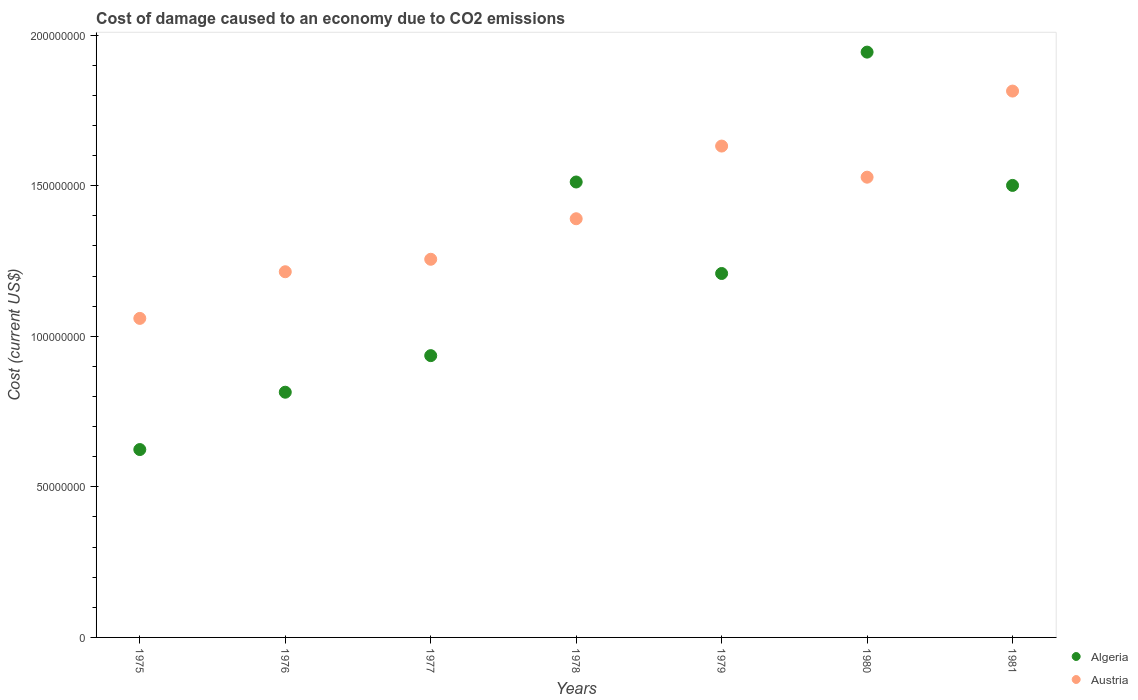What is the cost of damage caused due to CO2 emissisons in Algeria in 1977?
Your answer should be very brief. 9.36e+07. Across all years, what is the maximum cost of damage caused due to CO2 emissisons in Algeria?
Provide a short and direct response. 1.94e+08. Across all years, what is the minimum cost of damage caused due to CO2 emissisons in Austria?
Provide a succinct answer. 1.06e+08. In which year was the cost of damage caused due to CO2 emissisons in Algeria maximum?
Offer a very short reply. 1980. In which year was the cost of damage caused due to CO2 emissisons in Algeria minimum?
Give a very brief answer. 1975. What is the total cost of damage caused due to CO2 emissisons in Austria in the graph?
Keep it short and to the point. 9.89e+08. What is the difference between the cost of damage caused due to CO2 emissisons in Austria in 1976 and that in 1979?
Offer a terse response. -4.17e+07. What is the difference between the cost of damage caused due to CO2 emissisons in Austria in 1979 and the cost of damage caused due to CO2 emissisons in Algeria in 1976?
Offer a terse response. 8.17e+07. What is the average cost of damage caused due to CO2 emissisons in Algeria per year?
Offer a terse response. 1.22e+08. In the year 1977, what is the difference between the cost of damage caused due to CO2 emissisons in Austria and cost of damage caused due to CO2 emissisons in Algeria?
Your answer should be compact. 3.20e+07. What is the ratio of the cost of damage caused due to CO2 emissisons in Algeria in 1975 to that in 1981?
Ensure brevity in your answer.  0.42. Is the difference between the cost of damage caused due to CO2 emissisons in Austria in 1975 and 1981 greater than the difference between the cost of damage caused due to CO2 emissisons in Algeria in 1975 and 1981?
Your answer should be very brief. Yes. What is the difference between the highest and the second highest cost of damage caused due to CO2 emissisons in Austria?
Ensure brevity in your answer.  1.83e+07. What is the difference between the highest and the lowest cost of damage caused due to CO2 emissisons in Algeria?
Keep it short and to the point. 1.32e+08. Is the sum of the cost of damage caused due to CO2 emissisons in Algeria in 1976 and 1978 greater than the maximum cost of damage caused due to CO2 emissisons in Austria across all years?
Provide a short and direct response. Yes. Is the cost of damage caused due to CO2 emissisons in Austria strictly less than the cost of damage caused due to CO2 emissisons in Algeria over the years?
Ensure brevity in your answer.  No. How many dotlines are there?
Your response must be concise. 2. What is the difference between two consecutive major ticks on the Y-axis?
Provide a succinct answer. 5.00e+07. Are the values on the major ticks of Y-axis written in scientific E-notation?
Offer a very short reply. No. Does the graph contain any zero values?
Your response must be concise. No. Does the graph contain grids?
Give a very brief answer. No. How many legend labels are there?
Provide a short and direct response. 2. What is the title of the graph?
Provide a succinct answer. Cost of damage caused to an economy due to CO2 emissions. What is the label or title of the Y-axis?
Keep it short and to the point. Cost (current US$). What is the Cost (current US$) of Algeria in 1975?
Give a very brief answer. 6.24e+07. What is the Cost (current US$) in Austria in 1975?
Make the answer very short. 1.06e+08. What is the Cost (current US$) of Algeria in 1976?
Make the answer very short. 8.14e+07. What is the Cost (current US$) in Austria in 1976?
Your response must be concise. 1.21e+08. What is the Cost (current US$) in Algeria in 1977?
Provide a succinct answer. 9.36e+07. What is the Cost (current US$) of Austria in 1977?
Provide a succinct answer. 1.26e+08. What is the Cost (current US$) of Algeria in 1978?
Offer a very short reply. 1.51e+08. What is the Cost (current US$) of Austria in 1978?
Your response must be concise. 1.39e+08. What is the Cost (current US$) of Algeria in 1979?
Provide a short and direct response. 1.21e+08. What is the Cost (current US$) in Austria in 1979?
Provide a succinct answer. 1.63e+08. What is the Cost (current US$) of Algeria in 1980?
Make the answer very short. 1.94e+08. What is the Cost (current US$) of Austria in 1980?
Your response must be concise. 1.53e+08. What is the Cost (current US$) of Algeria in 1981?
Give a very brief answer. 1.50e+08. What is the Cost (current US$) in Austria in 1981?
Your response must be concise. 1.81e+08. Across all years, what is the maximum Cost (current US$) of Algeria?
Your answer should be very brief. 1.94e+08. Across all years, what is the maximum Cost (current US$) of Austria?
Ensure brevity in your answer.  1.81e+08. Across all years, what is the minimum Cost (current US$) in Algeria?
Your answer should be very brief. 6.24e+07. Across all years, what is the minimum Cost (current US$) in Austria?
Offer a very short reply. 1.06e+08. What is the total Cost (current US$) of Algeria in the graph?
Keep it short and to the point. 8.54e+08. What is the total Cost (current US$) of Austria in the graph?
Offer a terse response. 9.89e+08. What is the difference between the Cost (current US$) of Algeria in 1975 and that in 1976?
Give a very brief answer. -1.90e+07. What is the difference between the Cost (current US$) of Austria in 1975 and that in 1976?
Provide a succinct answer. -1.55e+07. What is the difference between the Cost (current US$) of Algeria in 1975 and that in 1977?
Your response must be concise. -3.12e+07. What is the difference between the Cost (current US$) in Austria in 1975 and that in 1977?
Keep it short and to the point. -1.96e+07. What is the difference between the Cost (current US$) of Algeria in 1975 and that in 1978?
Give a very brief answer. -8.88e+07. What is the difference between the Cost (current US$) of Austria in 1975 and that in 1978?
Make the answer very short. -3.31e+07. What is the difference between the Cost (current US$) in Algeria in 1975 and that in 1979?
Offer a very short reply. -5.85e+07. What is the difference between the Cost (current US$) in Austria in 1975 and that in 1979?
Provide a succinct answer. -5.72e+07. What is the difference between the Cost (current US$) in Algeria in 1975 and that in 1980?
Make the answer very short. -1.32e+08. What is the difference between the Cost (current US$) of Austria in 1975 and that in 1980?
Give a very brief answer. -4.69e+07. What is the difference between the Cost (current US$) of Algeria in 1975 and that in 1981?
Give a very brief answer. -8.77e+07. What is the difference between the Cost (current US$) in Austria in 1975 and that in 1981?
Ensure brevity in your answer.  -7.55e+07. What is the difference between the Cost (current US$) of Algeria in 1976 and that in 1977?
Keep it short and to the point. -1.21e+07. What is the difference between the Cost (current US$) in Austria in 1976 and that in 1977?
Your response must be concise. -4.14e+06. What is the difference between the Cost (current US$) in Algeria in 1976 and that in 1978?
Your answer should be very brief. -6.98e+07. What is the difference between the Cost (current US$) of Austria in 1976 and that in 1978?
Make the answer very short. -1.76e+07. What is the difference between the Cost (current US$) of Algeria in 1976 and that in 1979?
Make the answer very short. -3.94e+07. What is the difference between the Cost (current US$) in Austria in 1976 and that in 1979?
Offer a terse response. -4.17e+07. What is the difference between the Cost (current US$) of Algeria in 1976 and that in 1980?
Ensure brevity in your answer.  -1.13e+08. What is the difference between the Cost (current US$) of Austria in 1976 and that in 1980?
Make the answer very short. -3.14e+07. What is the difference between the Cost (current US$) of Algeria in 1976 and that in 1981?
Provide a succinct answer. -6.87e+07. What is the difference between the Cost (current US$) of Austria in 1976 and that in 1981?
Provide a succinct answer. -6.00e+07. What is the difference between the Cost (current US$) in Algeria in 1977 and that in 1978?
Your answer should be compact. -5.77e+07. What is the difference between the Cost (current US$) of Austria in 1977 and that in 1978?
Offer a very short reply. -1.35e+07. What is the difference between the Cost (current US$) of Algeria in 1977 and that in 1979?
Provide a short and direct response. -2.73e+07. What is the difference between the Cost (current US$) of Austria in 1977 and that in 1979?
Your response must be concise. -3.76e+07. What is the difference between the Cost (current US$) of Algeria in 1977 and that in 1980?
Keep it short and to the point. -1.01e+08. What is the difference between the Cost (current US$) of Austria in 1977 and that in 1980?
Offer a very short reply. -2.73e+07. What is the difference between the Cost (current US$) of Algeria in 1977 and that in 1981?
Offer a terse response. -5.65e+07. What is the difference between the Cost (current US$) in Austria in 1977 and that in 1981?
Your answer should be compact. -5.59e+07. What is the difference between the Cost (current US$) in Algeria in 1978 and that in 1979?
Your answer should be compact. 3.04e+07. What is the difference between the Cost (current US$) in Austria in 1978 and that in 1979?
Offer a very short reply. -2.41e+07. What is the difference between the Cost (current US$) of Algeria in 1978 and that in 1980?
Your response must be concise. -4.31e+07. What is the difference between the Cost (current US$) in Austria in 1978 and that in 1980?
Your answer should be very brief. -1.38e+07. What is the difference between the Cost (current US$) of Algeria in 1978 and that in 1981?
Your response must be concise. 1.13e+06. What is the difference between the Cost (current US$) of Austria in 1978 and that in 1981?
Provide a short and direct response. -4.24e+07. What is the difference between the Cost (current US$) of Algeria in 1979 and that in 1980?
Provide a short and direct response. -7.35e+07. What is the difference between the Cost (current US$) in Austria in 1979 and that in 1980?
Your answer should be very brief. 1.03e+07. What is the difference between the Cost (current US$) of Algeria in 1979 and that in 1981?
Offer a terse response. -2.92e+07. What is the difference between the Cost (current US$) of Austria in 1979 and that in 1981?
Ensure brevity in your answer.  -1.83e+07. What is the difference between the Cost (current US$) in Algeria in 1980 and that in 1981?
Give a very brief answer. 4.43e+07. What is the difference between the Cost (current US$) in Austria in 1980 and that in 1981?
Your response must be concise. -2.86e+07. What is the difference between the Cost (current US$) of Algeria in 1975 and the Cost (current US$) of Austria in 1976?
Your answer should be compact. -5.90e+07. What is the difference between the Cost (current US$) of Algeria in 1975 and the Cost (current US$) of Austria in 1977?
Give a very brief answer. -6.32e+07. What is the difference between the Cost (current US$) of Algeria in 1975 and the Cost (current US$) of Austria in 1978?
Your answer should be compact. -7.66e+07. What is the difference between the Cost (current US$) in Algeria in 1975 and the Cost (current US$) in Austria in 1979?
Your answer should be very brief. -1.01e+08. What is the difference between the Cost (current US$) of Algeria in 1975 and the Cost (current US$) of Austria in 1980?
Give a very brief answer. -9.04e+07. What is the difference between the Cost (current US$) in Algeria in 1975 and the Cost (current US$) in Austria in 1981?
Ensure brevity in your answer.  -1.19e+08. What is the difference between the Cost (current US$) of Algeria in 1976 and the Cost (current US$) of Austria in 1977?
Ensure brevity in your answer.  -4.41e+07. What is the difference between the Cost (current US$) in Algeria in 1976 and the Cost (current US$) in Austria in 1978?
Offer a very short reply. -5.76e+07. What is the difference between the Cost (current US$) of Algeria in 1976 and the Cost (current US$) of Austria in 1979?
Your answer should be very brief. -8.17e+07. What is the difference between the Cost (current US$) in Algeria in 1976 and the Cost (current US$) in Austria in 1980?
Offer a very short reply. -7.14e+07. What is the difference between the Cost (current US$) in Algeria in 1976 and the Cost (current US$) in Austria in 1981?
Give a very brief answer. -1.00e+08. What is the difference between the Cost (current US$) in Algeria in 1977 and the Cost (current US$) in Austria in 1978?
Keep it short and to the point. -4.55e+07. What is the difference between the Cost (current US$) in Algeria in 1977 and the Cost (current US$) in Austria in 1979?
Your answer should be compact. -6.96e+07. What is the difference between the Cost (current US$) in Algeria in 1977 and the Cost (current US$) in Austria in 1980?
Ensure brevity in your answer.  -5.93e+07. What is the difference between the Cost (current US$) of Algeria in 1977 and the Cost (current US$) of Austria in 1981?
Your answer should be compact. -8.79e+07. What is the difference between the Cost (current US$) in Algeria in 1978 and the Cost (current US$) in Austria in 1979?
Your answer should be compact. -1.19e+07. What is the difference between the Cost (current US$) of Algeria in 1978 and the Cost (current US$) of Austria in 1980?
Provide a succinct answer. -1.60e+06. What is the difference between the Cost (current US$) in Algeria in 1978 and the Cost (current US$) in Austria in 1981?
Ensure brevity in your answer.  -3.02e+07. What is the difference between the Cost (current US$) in Algeria in 1979 and the Cost (current US$) in Austria in 1980?
Your answer should be compact. -3.20e+07. What is the difference between the Cost (current US$) of Algeria in 1979 and the Cost (current US$) of Austria in 1981?
Keep it short and to the point. -6.06e+07. What is the difference between the Cost (current US$) of Algeria in 1980 and the Cost (current US$) of Austria in 1981?
Provide a short and direct response. 1.29e+07. What is the average Cost (current US$) of Algeria per year?
Provide a short and direct response. 1.22e+08. What is the average Cost (current US$) in Austria per year?
Offer a terse response. 1.41e+08. In the year 1975, what is the difference between the Cost (current US$) in Algeria and Cost (current US$) in Austria?
Keep it short and to the point. -4.36e+07. In the year 1976, what is the difference between the Cost (current US$) in Algeria and Cost (current US$) in Austria?
Provide a succinct answer. -4.00e+07. In the year 1977, what is the difference between the Cost (current US$) in Algeria and Cost (current US$) in Austria?
Give a very brief answer. -3.20e+07. In the year 1978, what is the difference between the Cost (current US$) in Algeria and Cost (current US$) in Austria?
Your answer should be compact. 1.22e+07. In the year 1979, what is the difference between the Cost (current US$) of Algeria and Cost (current US$) of Austria?
Your answer should be very brief. -4.23e+07. In the year 1980, what is the difference between the Cost (current US$) in Algeria and Cost (current US$) in Austria?
Offer a terse response. 4.15e+07. In the year 1981, what is the difference between the Cost (current US$) of Algeria and Cost (current US$) of Austria?
Provide a succinct answer. -3.13e+07. What is the ratio of the Cost (current US$) in Algeria in 1975 to that in 1976?
Provide a short and direct response. 0.77. What is the ratio of the Cost (current US$) in Austria in 1975 to that in 1976?
Keep it short and to the point. 0.87. What is the ratio of the Cost (current US$) of Austria in 1975 to that in 1977?
Your answer should be compact. 0.84. What is the ratio of the Cost (current US$) in Algeria in 1975 to that in 1978?
Keep it short and to the point. 0.41. What is the ratio of the Cost (current US$) in Austria in 1975 to that in 1978?
Make the answer very short. 0.76. What is the ratio of the Cost (current US$) of Algeria in 1975 to that in 1979?
Your answer should be compact. 0.52. What is the ratio of the Cost (current US$) of Austria in 1975 to that in 1979?
Ensure brevity in your answer.  0.65. What is the ratio of the Cost (current US$) in Algeria in 1975 to that in 1980?
Ensure brevity in your answer.  0.32. What is the ratio of the Cost (current US$) in Austria in 1975 to that in 1980?
Your answer should be compact. 0.69. What is the ratio of the Cost (current US$) of Algeria in 1975 to that in 1981?
Ensure brevity in your answer.  0.42. What is the ratio of the Cost (current US$) of Austria in 1975 to that in 1981?
Your answer should be compact. 0.58. What is the ratio of the Cost (current US$) in Algeria in 1976 to that in 1977?
Ensure brevity in your answer.  0.87. What is the ratio of the Cost (current US$) in Algeria in 1976 to that in 1978?
Keep it short and to the point. 0.54. What is the ratio of the Cost (current US$) of Austria in 1976 to that in 1978?
Provide a succinct answer. 0.87. What is the ratio of the Cost (current US$) in Algeria in 1976 to that in 1979?
Offer a terse response. 0.67. What is the ratio of the Cost (current US$) of Austria in 1976 to that in 1979?
Make the answer very short. 0.74. What is the ratio of the Cost (current US$) in Algeria in 1976 to that in 1980?
Keep it short and to the point. 0.42. What is the ratio of the Cost (current US$) of Austria in 1976 to that in 1980?
Give a very brief answer. 0.79. What is the ratio of the Cost (current US$) of Algeria in 1976 to that in 1981?
Your answer should be very brief. 0.54. What is the ratio of the Cost (current US$) of Austria in 1976 to that in 1981?
Offer a terse response. 0.67. What is the ratio of the Cost (current US$) of Algeria in 1977 to that in 1978?
Keep it short and to the point. 0.62. What is the ratio of the Cost (current US$) of Austria in 1977 to that in 1978?
Provide a short and direct response. 0.9. What is the ratio of the Cost (current US$) in Algeria in 1977 to that in 1979?
Ensure brevity in your answer.  0.77. What is the ratio of the Cost (current US$) of Austria in 1977 to that in 1979?
Your answer should be compact. 0.77. What is the ratio of the Cost (current US$) in Algeria in 1977 to that in 1980?
Your answer should be very brief. 0.48. What is the ratio of the Cost (current US$) of Austria in 1977 to that in 1980?
Ensure brevity in your answer.  0.82. What is the ratio of the Cost (current US$) of Algeria in 1977 to that in 1981?
Your answer should be compact. 0.62. What is the ratio of the Cost (current US$) in Austria in 1977 to that in 1981?
Your answer should be very brief. 0.69. What is the ratio of the Cost (current US$) in Algeria in 1978 to that in 1979?
Offer a very short reply. 1.25. What is the ratio of the Cost (current US$) of Austria in 1978 to that in 1979?
Offer a terse response. 0.85. What is the ratio of the Cost (current US$) of Algeria in 1978 to that in 1980?
Keep it short and to the point. 0.78. What is the ratio of the Cost (current US$) of Austria in 1978 to that in 1980?
Provide a succinct answer. 0.91. What is the ratio of the Cost (current US$) of Algeria in 1978 to that in 1981?
Give a very brief answer. 1.01. What is the ratio of the Cost (current US$) of Austria in 1978 to that in 1981?
Provide a short and direct response. 0.77. What is the ratio of the Cost (current US$) of Algeria in 1979 to that in 1980?
Offer a terse response. 0.62. What is the ratio of the Cost (current US$) in Austria in 1979 to that in 1980?
Offer a terse response. 1.07. What is the ratio of the Cost (current US$) of Algeria in 1979 to that in 1981?
Keep it short and to the point. 0.81. What is the ratio of the Cost (current US$) in Austria in 1979 to that in 1981?
Provide a succinct answer. 0.9. What is the ratio of the Cost (current US$) in Algeria in 1980 to that in 1981?
Provide a succinct answer. 1.29. What is the ratio of the Cost (current US$) in Austria in 1980 to that in 1981?
Make the answer very short. 0.84. What is the difference between the highest and the second highest Cost (current US$) in Algeria?
Offer a terse response. 4.31e+07. What is the difference between the highest and the second highest Cost (current US$) in Austria?
Make the answer very short. 1.83e+07. What is the difference between the highest and the lowest Cost (current US$) of Algeria?
Your response must be concise. 1.32e+08. What is the difference between the highest and the lowest Cost (current US$) in Austria?
Your answer should be very brief. 7.55e+07. 